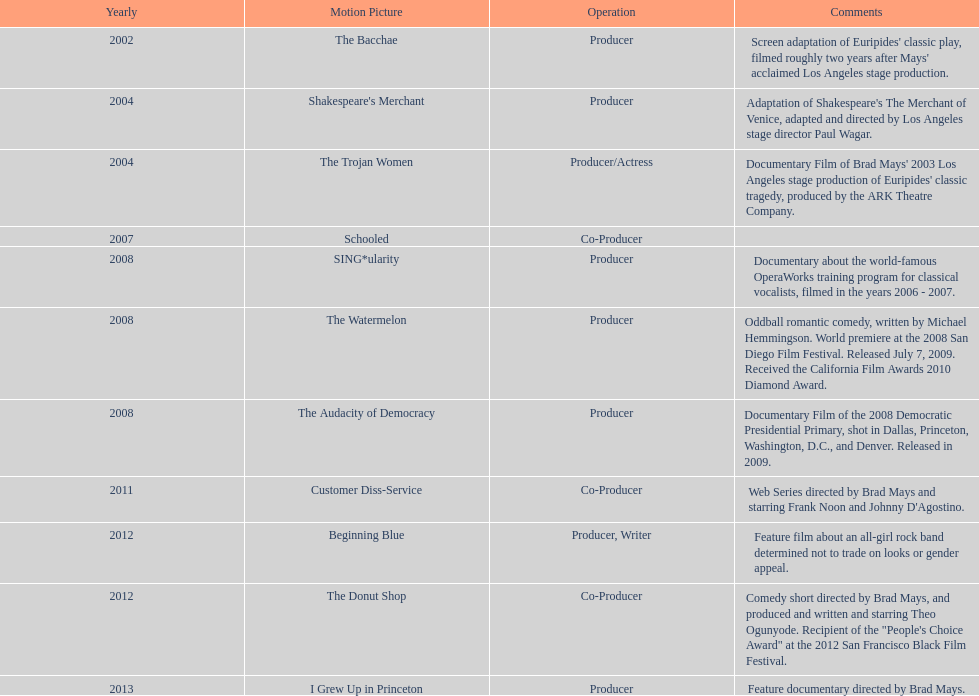Which film was before the audacity of democracy? The Watermelon. 